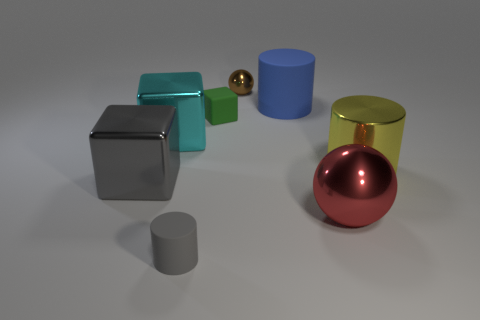What number of other objects are there of the same size as the green rubber object?
Your answer should be compact. 2. What number of objects are rubber cylinders or balls that are behind the yellow cylinder?
Provide a short and direct response. 3. Is the big cyan thing made of the same material as the blue cylinder?
Keep it short and to the point. No. How many other things are there of the same shape as the large gray object?
Ensure brevity in your answer.  2. What size is the object that is both left of the big rubber thing and behind the small green block?
Offer a very short reply. Small. What number of matte objects are brown spheres or blue cylinders?
Keep it short and to the point. 1. Do the tiny gray rubber thing that is left of the brown object and the rubber thing that is right of the tiny ball have the same shape?
Offer a terse response. Yes. Is there a yellow cylinder made of the same material as the large blue thing?
Your answer should be compact. No. The shiny cylinder has what color?
Offer a very short reply. Yellow. What is the size of the cube in front of the big yellow object?
Offer a terse response. Large. 